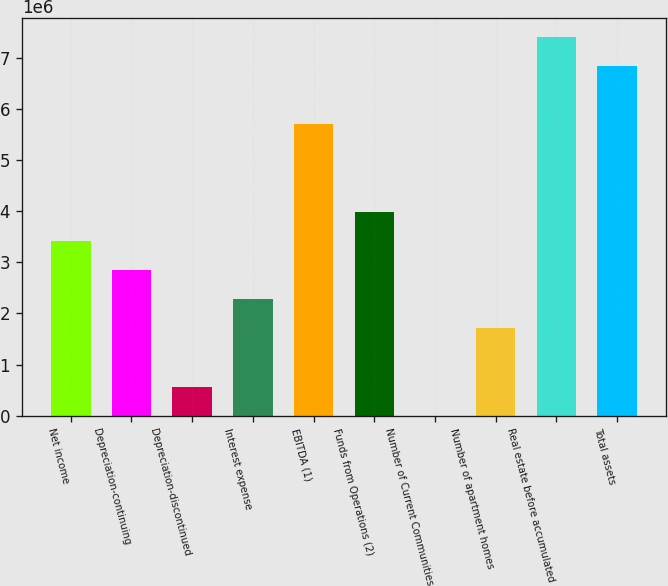Convert chart to OTSL. <chart><loc_0><loc_0><loc_500><loc_500><bar_chart><fcel>Net income<fcel>Depreciation-continuing<fcel>Depreciation-discontinued<fcel>Interest expense<fcel>EBITDA (1)<fcel>Funds from Operations (2)<fcel>Number of Current Communities<fcel>Number of apartment homes<fcel>Real estate before accumulated<fcel>Total assets<nl><fcel>3.41834e+06<fcel>2.84864e+06<fcel>569839<fcel>2.27894e+06<fcel>5.69714e+06<fcel>3.98804e+06<fcel>138<fcel>1.70924e+06<fcel>7.40625e+06<fcel>6.83655e+06<nl></chart> 